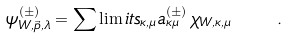<formula> <loc_0><loc_0><loc_500><loc_500>\psi _ { W , \vec { p } , \lambda } ^ { ( \pm ) } = \sum \lim i t s _ { \kappa , \mu } a ^ { ( \pm ) } _ { \kappa \mu } \, \chi _ { W , \kappa , \mu } \quad .</formula> 